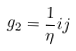<formula> <loc_0><loc_0><loc_500><loc_500>g _ { 2 } = \frac { 1 } { \eta } i j</formula> 